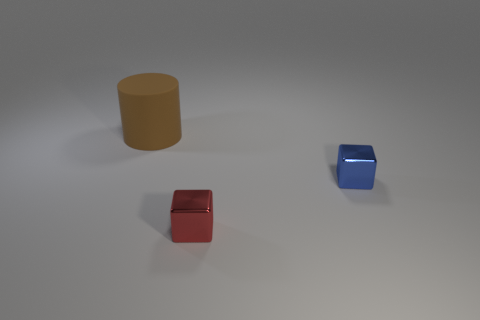Add 1 tiny red rubber cylinders. How many objects exist? 4 Subtract all brown cubes. Subtract all blue spheres. How many cubes are left? 2 Subtract all cylinders. How many objects are left? 2 Add 2 big matte objects. How many big matte objects are left? 3 Add 1 tiny green shiny cylinders. How many tiny green shiny cylinders exist? 1 Subtract 0 red cylinders. How many objects are left? 3 Subtract all large cylinders. Subtract all red metal objects. How many objects are left? 1 